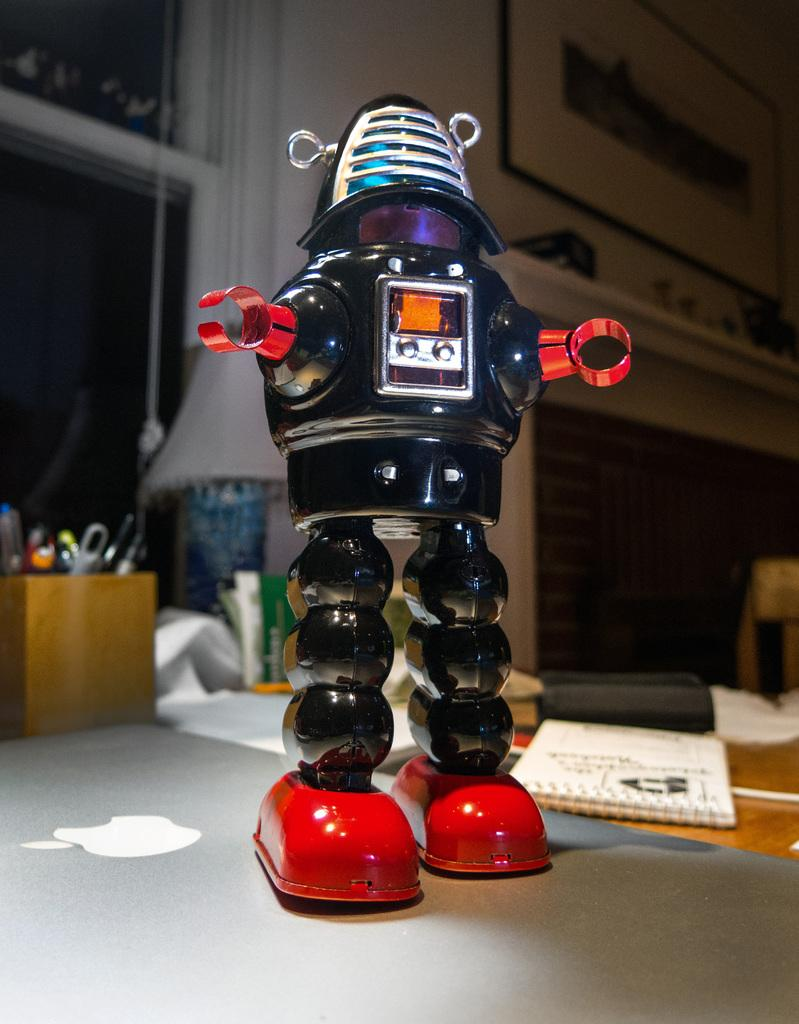What is the main subject of the image? The main subject of the image is a robot standing on a laptop. What other objects can be seen in the image? There is a pen stand, books, a lamp, papers on a table, and a window on the wall in the image. What might be used for writing or drawing in the image? The pen stand in the image might be used for holding pens or pencils for writing or drawing. What is the source of light in the image? The lamp in the image is the source of light. What story is the robot telling the children in the image? There are no children present in the image, and the robot is not telling a story. 